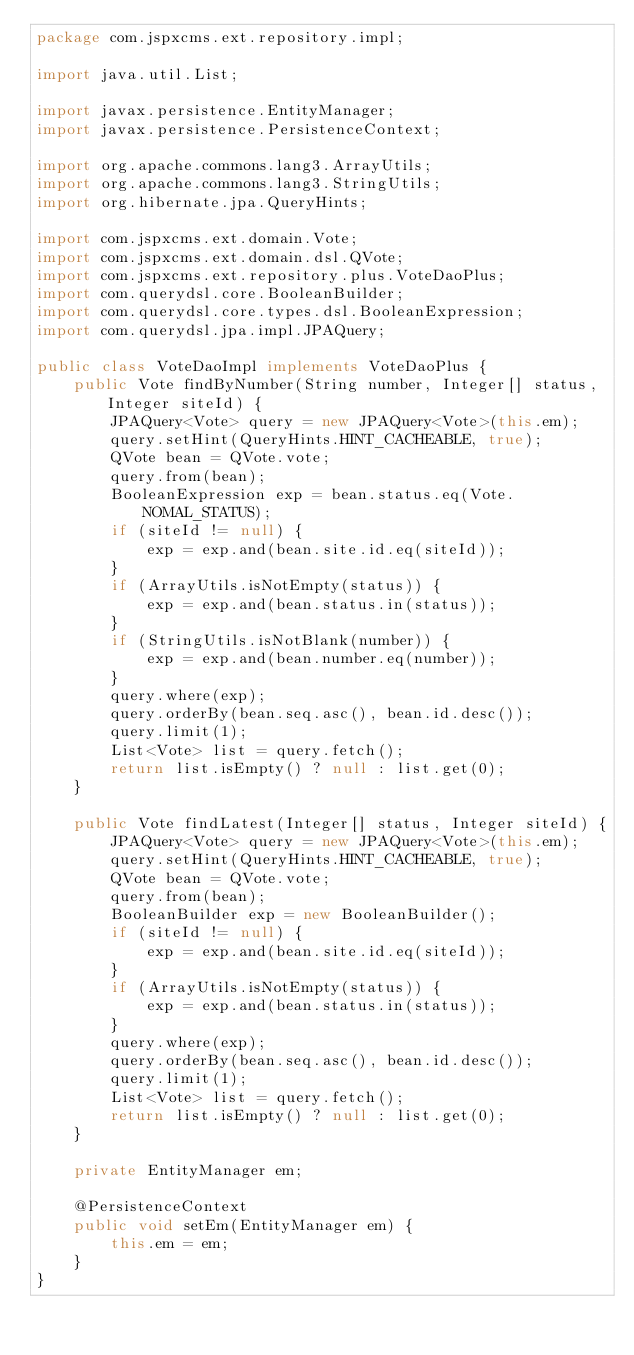Convert code to text. <code><loc_0><loc_0><loc_500><loc_500><_Java_>package com.jspxcms.ext.repository.impl;

import java.util.List;

import javax.persistence.EntityManager;
import javax.persistence.PersistenceContext;

import org.apache.commons.lang3.ArrayUtils;
import org.apache.commons.lang3.StringUtils;
import org.hibernate.jpa.QueryHints;

import com.jspxcms.ext.domain.Vote;
import com.jspxcms.ext.domain.dsl.QVote;
import com.jspxcms.ext.repository.plus.VoteDaoPlus;
import com.querydsl.core.BooleanBuilder;
import com.querydsl.core.types.dsl.BooleanExpression;
import com.querydsl.jpa.impl.JPAQuery;

public class VoteDaoImpl implements VoteDaoPlus {
	public Vote findByNumber(String number, Integer[] status, Integer siteId) {
		JPAQuery<Vote> query = new JPAQuery<Vote>(this.em);
		query.setHint(QueryHints.HINT_CACHEABLE, true);
		QVote bean = QVote.vote;
		query.from(bean);
		BooleanExpression exp = bean.status.eq(Vote.NOMAL_STATUS);
		if (siteId != null) {
			exp = exp.and(bean.site.id.eq(siteId));
		}
		if (ArrayUtils.isNotEmpty(status)) {
			exp = exp.and(bean.status.in(status));
		}
		if (StringUtils.isNotBlank(number)) {
			exp = exp.and(bean.number.eq(number));
		}
		query.where(exp);
		query.orderBy(bean.seq.asc(), bean.id.desc());
		query.limit(1);
		List<Vote> list = query.fetch();
		return list.isEmpty() ? null : list.get(0);
	}

	public Vote findLatest(Integer[] status, Integer siteId) {
		JPAQuery<Vote> query = new JPAQuery<Vote>(this.em);
		query.setHint(QueryHints.HINT_CACHEABLE, true);
		QVote bean = QVote.vote;
		query.from(bean);
		BooleanBuilder exp = new BooleanBuilder();
		if (siteId != null) {
			exp = exp.and(bean.site.id.eq(siteId));
		}
		if (ArrayUtils.isNotEmpty(status)) {
			exp = exp.and(bean.status.in(status));
		}
		query.where(exp);
		query.orderBy(bean.seq.asc(), bean.id.desc());
		query.limit(1);
		List<Vote> list = query.fetch();
		return list.isEmpty() ? null : list.get(0);
	}

	private EntityManager em;

	@PersistenceContext
	public void setEm(EntityManager em) {
		this.em = em;
	}
}
</code> 